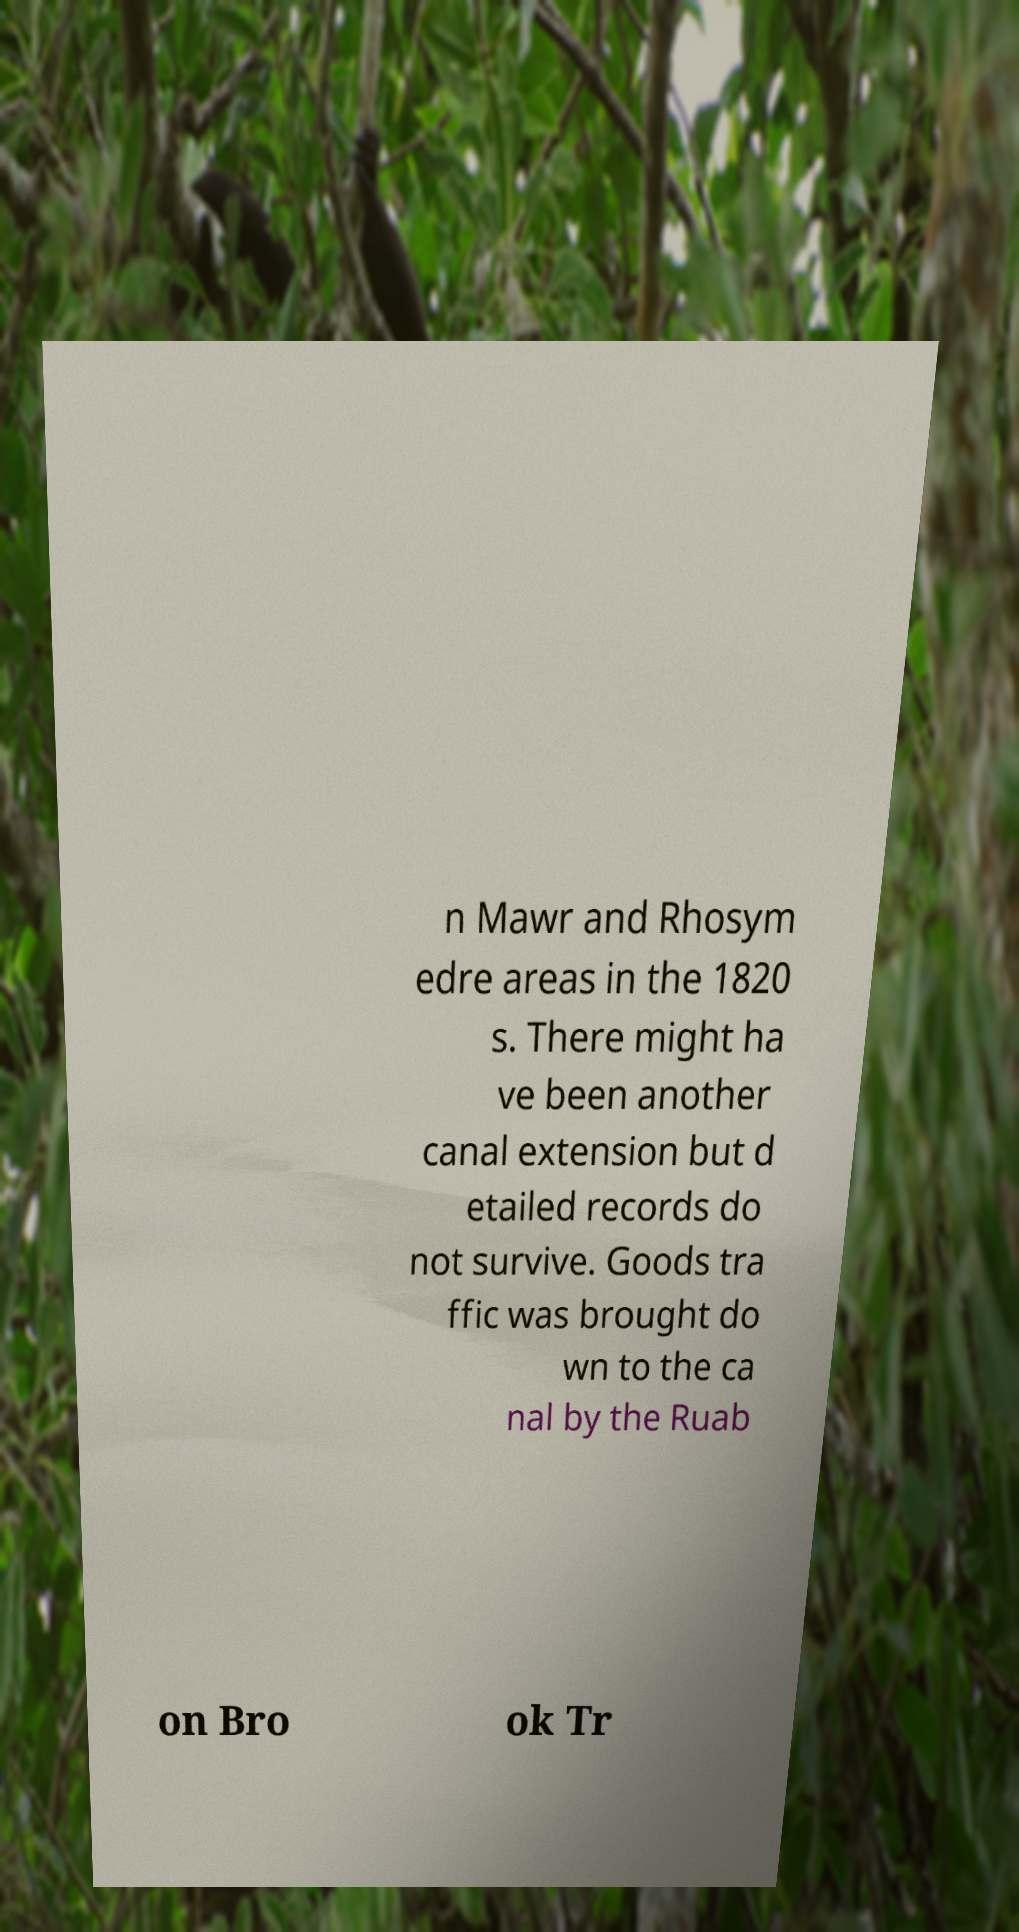For documentation purposes, I need the text within this image transcribed. Could you provide that? n Mawr and Rhosym edre areas in the 1820 s. There might ha ve been another canal extension but d etailed records do not survive. Goods tra ffic was brought do wn to the ca nal by the Ruab on Bro ok Tr 